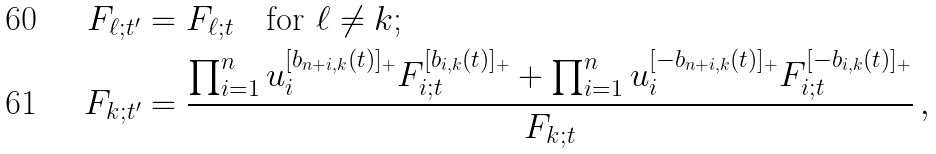Convert formula to latex. <formula><loc_0><loc_0><loc_500><loc_500>F _ { \ell ; t ^ { \prime } } & = F _ { \ell ; t } \quad \text {for $\ell\neq  k$;} \\ F _ { k ; t ^ { \prime } } & = \frac { \prod _ { i = 1 } ^ { n } u _ { i } ^ { [ b _ { n + i , k } ( t ) ] _ { + } } F _ { i ; t } ^ { [ b _ { i , k } ( t ) ] _ { + } } + \prod _ { i = 1 } ^ { n } u _ { i } ^ { [ - b _ { n + i , k } ( t ) ] _ { + } } F _ { i ; t } ^ { [ - b _ { i , k } ( t ) ] _ { + } } } { F _ { k ; t } } \, ,</formula> 